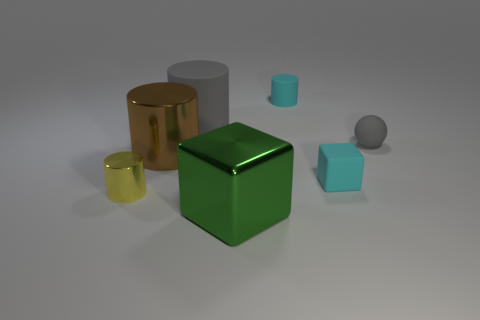Add 1 small gray rubber things. How many objects exist? 8 Subtract all spheres. How many objects are left? 6 Add 4 cyan matte cylinders. How many cyan matte cylinders exist? 5 Subtract 1 gray cylinders. How many objects are left? 6 Subtract all small matte balls. Subtract all small cyan rubber things. How many objects are left? 4 Add 4 tiny balls. How many tiny balls are left? 5 